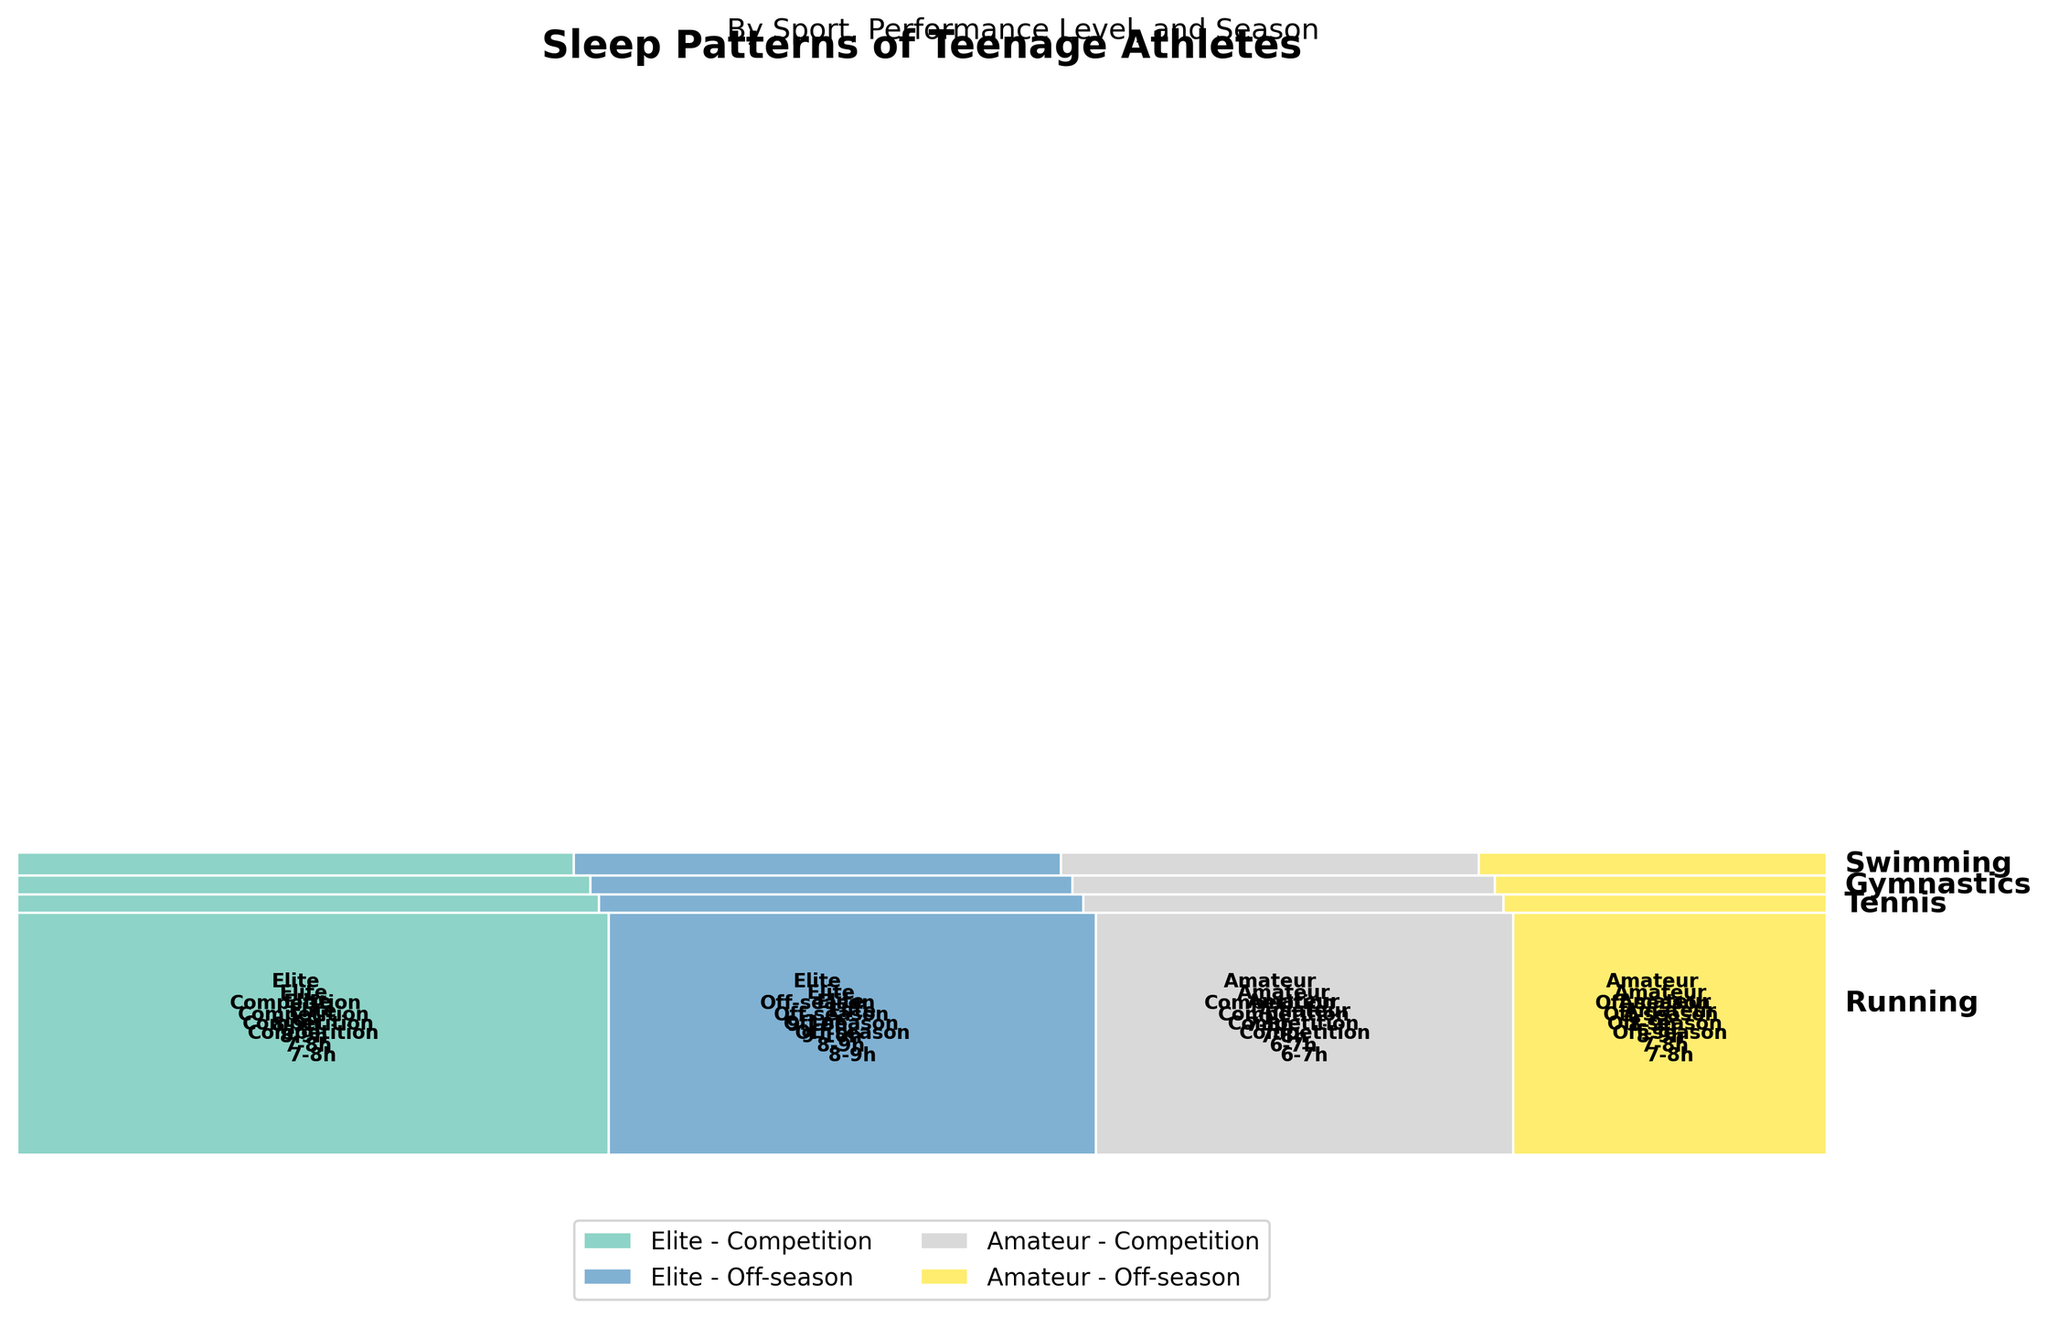What is the title of the Mosaic Plot? The title is usually found at the top of the figure and summarizes the main topic being visualized. In this case, it reads "Sleep Patterns of Teenage Athletes."
Answer: Sleep Patterns of Teenage Athletes Which sport has the highest total proportion of sleep hours during the competition season for elite athletes? To answer this, we need to look at the relative size of segments corresponding to elite athletes in competition season for each sport. The largest segment indicates the highest proportion.
Answer: Running What sleep hours are most common among amateur gymnasts during the competition season? Locate the section of the mosaic plot related to amateur gymnasts during the competition season, then identify the most frequently occurring sleep hours.
Answer: 6-7 hours Compare the sleep hours of elite swimmers during competition season and off-season. Which season has higher sleep hours? Find the sections corresponding to elite swimmers in both competition and off-seasons, then compare the stated sleep hours in both.
Answer: Off-season Which performance level shows greater change in sleep hours between competition season and off-season for tennis players? Analyze the segments for tennis players in both seasons and compare the sleep hours for elite and amateur performance levels.
Answer: Elite What are the sleep hours for elite runners during the off-season? Look at the mosaic segment that includes elite runners in the off-season and identify the sleep hours listed inside the segment.
Answer: 9-10 hours What sport shows the least variation in sleep hours between competition and off-seasons for amateurs? To determine this, compare the sleep hours between seasons for amateur athletes across each sport and identify the sport with the smallest difference in sleep hours.
Answer: Swimming How do the sleep patterns of elite gymnasts during the competition season compare to those of elite swimmers in the same season? Locate the segments for elite gymnasts and elite swimmers during the competition season and compare the sleep hours listed inside these segments.
Answer: Gymnasts: 7-8 hours; Swimmers: 8-9 hours Which group has a higher proportion of athletes sleeping 8-9 hours during the off-season: elite runners or elite swimmers? Compare the size of the 8-9 hours segments for elite runners and elite swimmers during the off-season to see which is larger.
Answer: Swimmers 